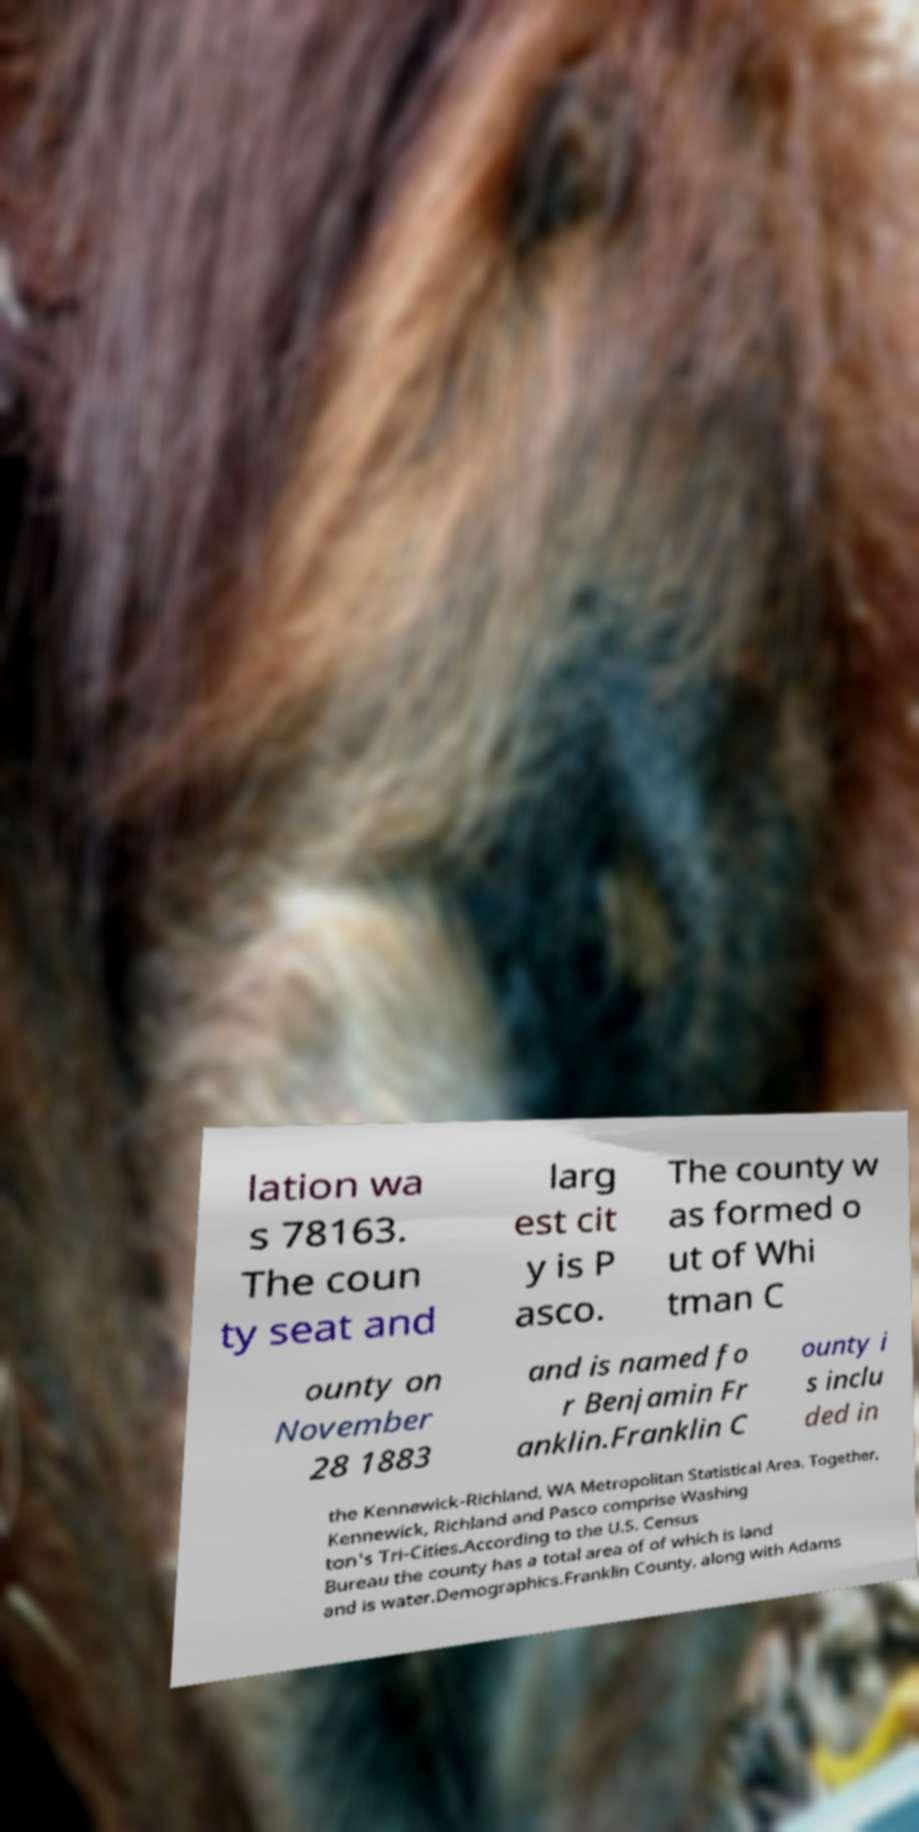For documentation purposes, I need the text within this image transcribed. Could you provide that? lation wa s 78163. The coun ty seat and larg est cit y is P asco. The county w as formed o ut of Whi tman C ounty on November 28 1883 and is named fo r Benjamin Fr anklin.Franklin C ounty i s inclu ded in the Kennewick-Richland, WA Metropolitan Statistical Area. Together, Kennewick, Richland and Pasco comprise Washing ton's Tri-Cities.According to the U.S. Census Bureau the county has a total area of of which is land and is water.Demographics.Franklin County, along with Adams 